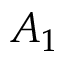Convert formula to latex. <formula><loc_0><loc_0><loc_500><loc_500>A _ { 1 }</formula> 